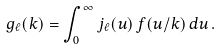Convert formula to latex. <formula><loc_0><loc_0><loc_500><loc_500>g _ { \ell } ( k ) = \int _ { 0 } ^ { \infty } j _ { \ell } ( u ) \, f ( u / k ) \, d u \, .</formula> 